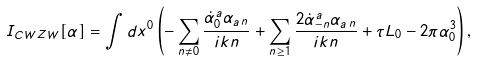Convert formula to latex. <formula><loc_0><loc_0><loc_500><loc_500>I _ { C W Z W } [ \alpha ] = \int d x ^ { 0 } \left ( - \sum _ { n \neq 0 } \frac { \dot { \alpha } _ { 0 } ^ { a } \alpha _ { a \, n } } { i k n } + \sum _ { n \geq 1 } \frac { 2 \dot { \alpha } _ { - n } ^ { a } \alpha _ { a \, n } } { i k n } + \tau L _ { 0 } - 2 \pi \alpha _ { 0 } ^ { 3 } \right ) ,</formula> 